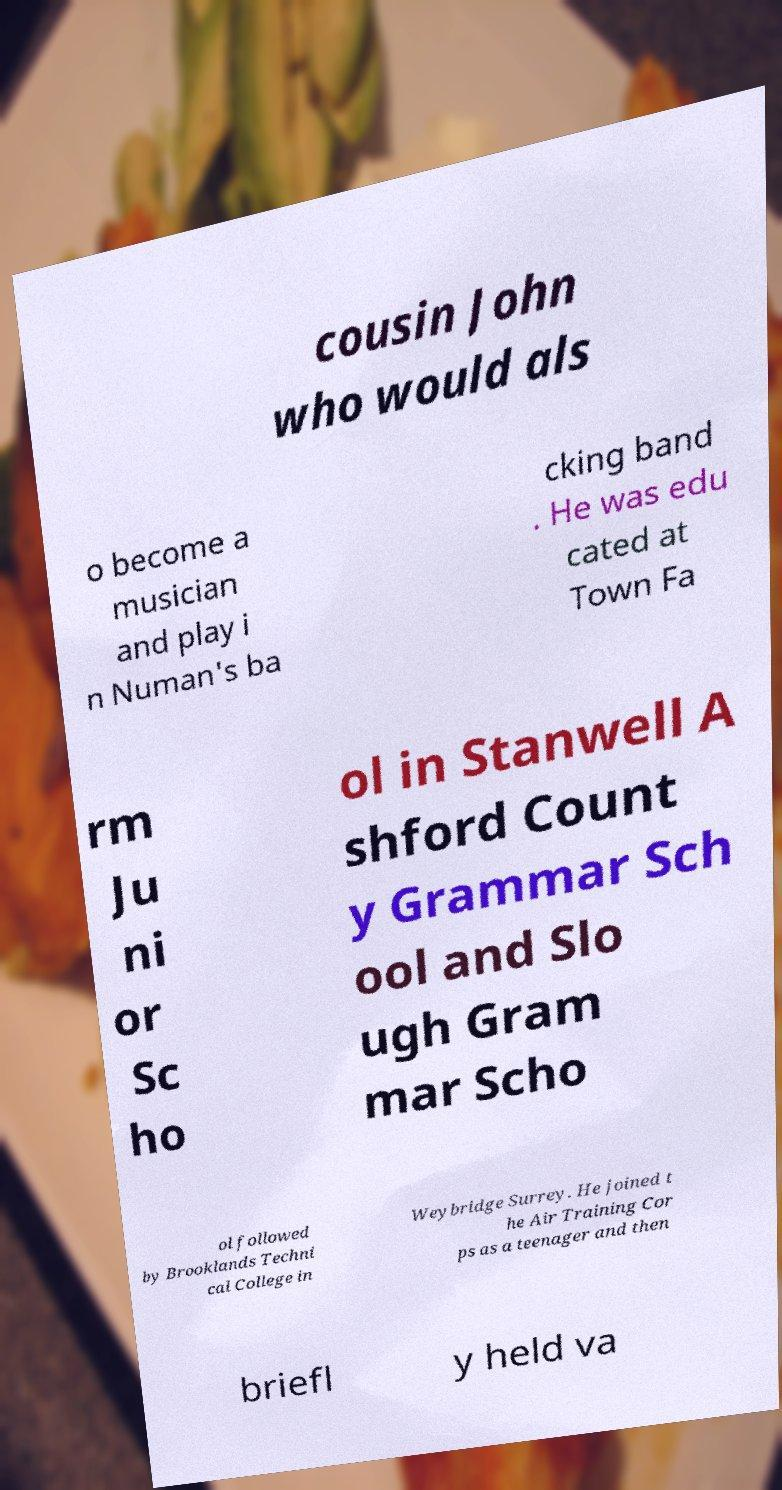There's text embedded in this image that I need extracted. Can you transcribe it verbatim? cousin John who would als o become a musician and play i n Numan's ba cking band . He was edu cated at Town Fa rm Ju ni or Sc ho ol in Stanwell A shford Count y Grammar Sch ool and Slo ugh Gram mar Scho ol followed by Brooklands Techni cal College in Weybridge Surrey. He joined t he Air Training Cor ps as a teenager and then briefl y held va 